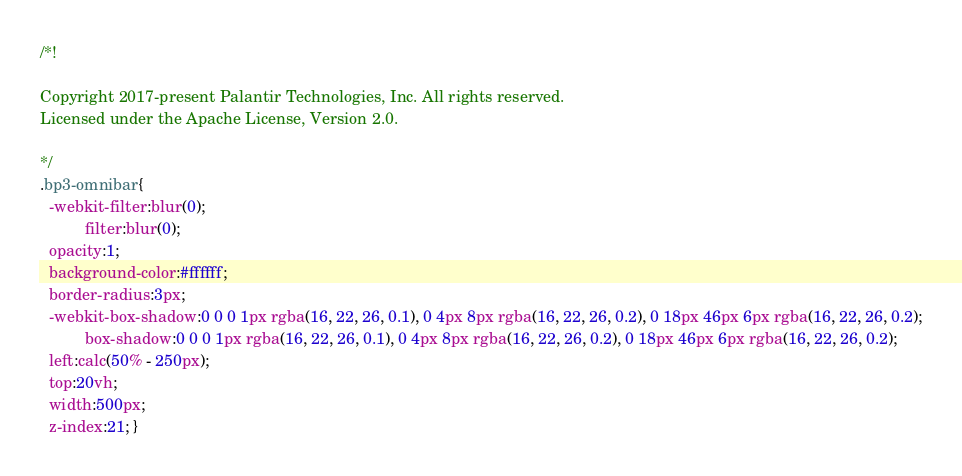<code> <loc_0><loc_0><loc_500><loc_500><_CSS_>/*!

Copyright 2017-present Palantir Technologies, Inc. All rights reserved.
Licensed under the Apache License, Version 2.0.

*/
.bp3-omnibar{
  -webkit-filter:blur(0);
          filter:blur(0);
  opacity:1;
  background-color:#ffffff;
  border-radius:3px;
  -webkit-box-shadow:0 0 0 1px rgba(16, 22, 26, 0.1), 0 4px 8px rgba(16, 22, 26, 0.2), 0 18px 46px 6px rgba(16, 22, 26, 0.2);
          box-shadow:0 0 0 1px rgba(16, 22, 26, 0.1), 0 4px 8px rgba(16, 22, 26, 0.2), 0 18px 46px 6px rgba(16, 22, 26, 0.2);
  left:calc(50% - 250px);
  top:20vh;
  width:500px;
  z-index:21; }</code> 